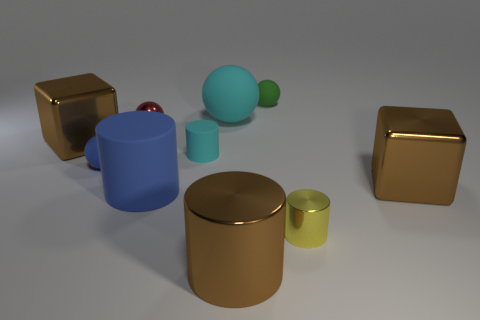What materials are the objects in the image made of? The objects in the image seem to resemble materials such as polished metal for the shiny golden cubes and cylinder, matte plastic for the green objects, and perhaps ceramic for the glossy red sphere and matte blue cylinder. However, without additional context, it's not possible to determine the exact materials. 